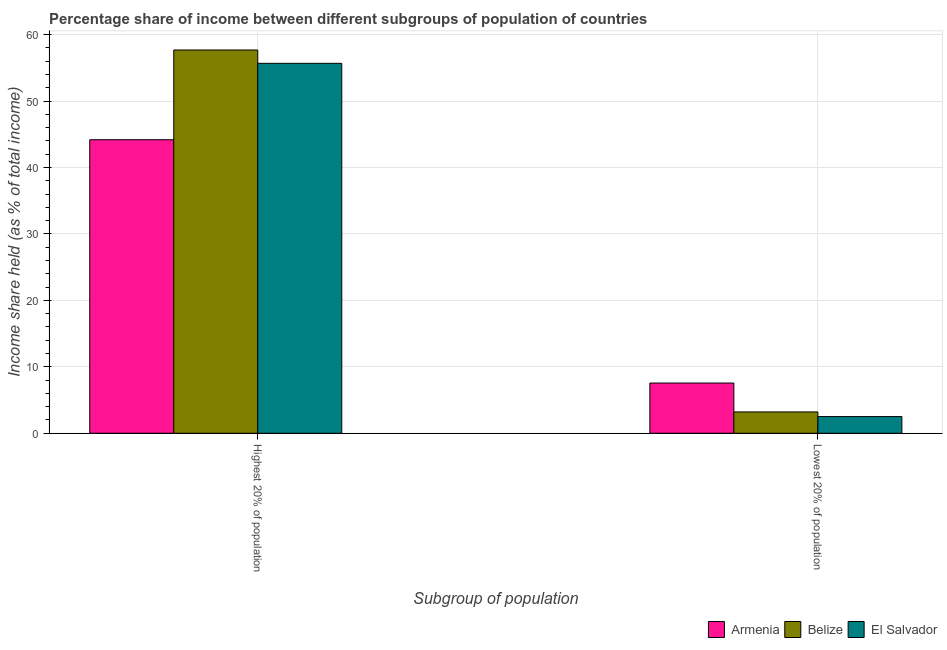How many groups of bars are there?
Offer a terse response. 2. Are the number of bars per tick equal to the number of legend labels?
Provide a succinct answer. Yes. What is the label of the 1st group of bars from the left?
Your response must be concise. Highest 20% of population. What is the income share held by lowest 20% of the population in El Salvador?
Provide a succinct answer. 2.51. Across all countries, what is the maximum income share held by highest 20% of the population?
Give a very brief answer. 57.69. Across all countries, what is the minimum income share held by lowest 20% of the population?
Your response must be concise. 2.51. In which country was the income share held by lowest 20% of the population maximum?
Your response must be concise. Armenia. In which country was the income share held by lowest 20% of the population minimum?
Your answer should be very brief. El Salvador. What is the total income share held by lowest 20% of the population in the graph?
Offer a terse response. 13.28. What is the difference between the income share held by highest 20% of the population in Armenia and that in El Salvador?
Your answer should be compact. -11.5. What is the difference between the income share held by highest 20% of the population in El Salvador and the income share held by lowest 20% of the population in Armenia?
Keep it short and to the point. 48.12. What is the average income share held by highest 20% of the population per country?
Provide a short and direct response. 52.52. What is the difference between the income share held by highest 20% of the population and income share held by lowest 20% of the population in Armenia?
Your answer should be very brief. 36.62. In how many countries, is the income share held by highest 20% of the population greater than 4 %?
Provide a short and direct response. 3. What is the ratio of the income share held by lowest 20% of the population in Armenia to that in El Salvador?
Provide a succinct answer. 3.01. Is the income share held by lowest 20% of the population in Armenia less than that in El Salvador?
Provide a succinct answer. No. In how many countries, is the income share held by lowest 20% of the population greater than the average income share held by lowest 20% of the population taken over all countries?
Your answer should be compact. 1. What does the 2nd bar from the left in Lowest 20% of population represents?
Provide a succinct answer. Belize. What does the 3rd bar from the right in Highest 20% of population represents?
Make the answer very short. Armenia. Are all the bars in the graph horizontal?
Give a very brief answer. No. What is the difference between two consecutive major ticks on the Y-axis?
Keep it short and to the point. 10. Are the values on the major ticks of Y-axis written in scientific E-notation?
Offer a very short reply. No. Where does the legend appear in the graph?
Your answer should be compact. Bottom right. How are the legend labels stacked?
Your answer should be very brief. Horizontal. What is the title of the graph?
Make the answer very short. Percentage share of income between different subgroups of population of countries. Does "Malaysia" appear as one of the legend labels in the graph?
Your answer should be compact. No. What is the label or title of the X-axis?
Ensure brevity in your answer.  Subgroup of population. What is the label or title of the Y-axis?
Your response must be concise. Income share held (as % of total income). What is the Income share held (as % of total income) in Armenia in Highest 20% of population?
Make the answer very short. 44.18. What is the Income share held (as % of total income) of Belize in Highest 20% of population?
Offer a very short reply. 57.69. What is the Income share held (as % of total income) in El Salvador in Highest 20% of population?
Offer a very short reply. 55.68. What is the Income share held (as % of total income) of Armenia in Lowest 20% of population?
Make the answer very short. 7.56. What is the Income share held (as % of total income) of Belize in Lowest 20% of population?
Make the answer very short. 3.21. What is the Income share held (as % of total income) in El Salvador in Lowest 20% of population?
Give a very brief answer. 2.51. Across all Subgroup of population, what is the maximum Income share held (as % of total income) in Armenia?
Ensure brevity in your answer.  44.18. Across all Subgroup of population, what is the maximum Income share held (as % of total income) in Belize?
Your response must be concise. 57.69. Across all Subgroup of population, what is the maximum Income share held (as % of total income) of El Salvador?
Ensure brevity in your answer.  55.68. Across all Subgroup of population, what is the minimum Income share held (as % of total income) of Armenia?
Make the answer very short. 7.56. Across all Subgroup of population, what is the minimum Income share held (as % of total income) of Belize?
Your response must be concise. 3.21. Across all Subgroup of population, what is the minimum Income share held (as % of total income) of El Salvador?
Ensure brevity in your answer.  2.51. What is the total Income share held (as % of total income) in Armenia in the graph?
Your answer should be very brief. 51.74. What is the total Income share held (as % of total income) of Belize in the graph?
Provide a short and direct response. 60.9. What is the total Income share held (as % of total income) in El Salvador in the graph?
Your answer should be very brief. 58.19. What is the difference between the Income share held (as % of total income) in Armenia in Highest 20% of population and that in Lowest 20% of population?
Your response must be concise. 36.62. What is the difference between the Income share held (as % of total income) in Belize in Highest 20% of population and that in Lowest 20% of population?
Your answer should be compact. 54.48. What is the difference between the Income share held (as % of total income) of El Salvador in Highest 20% of population and that in Lowest 20% of population?
Offer a very short reply. 53.17. What is the difference between the Income share held (as % of total income) of Armenia in Highest 20% of population and the Income share held (as % of total income) of Belize in Lowest 20% of population?
Keep it short and to the point. 40.97. What is the difference between the Income share held (as % of total income) of Armenia in Highest 20% of population and the Income share held (as % of total income) of El Salvador in Lowest 20% of population?
Ensure brevity in your answer.  41.67. What is the difference between the Income share held (as % of total income) in Belize in Highest 20% of population and the Income share held (as % of total income) in El Salvador in Lowest 20% of population?
Keep it short and to the point. 55.18. What is the average Income share held (as % of total income) of Armenia per Subgroup of population?
Provide a succinct answer. 25.87. What is the average Income share held (as % of total income) of Belize per Subgroup of population?
Give a very brief answer. 30.45. What is the average Income share held (as % of total income) of El Salvador per Subgroup of population?
Your answer should be compact. 29.09. What is the difference between the Income share held (as % of total income) of Armenia and Income share held (as % of total income) of Belize in Highest 20% of population?
Your answer should be very brief. -13.51. What is the difference between the Income share held (as % of total income) of Armenia and Income share held (as % of total income) of El Salvador in Highest 20% of population?
Ensure brevity in your answer.  -11.5. What is the difference between the Income share held (as % of total income) in Belize and Income share held (as % of total income) in El Salvador in Highest 20% of population?
Your answer should be compact. 2.01. What is the difference between the Income share held (as % of total income) of Armenia and Income share held (as % of total income) of Belize in Lowest 20% of population?
Your answer should be very brief. 4.35. What is the difference between the Income share held (as % of total income) in Armenia and Income share held (as % of total income) in El Salvador in Lowest 20% of population?
Offer a terse response. 5.05. What is the difference between the Income share held (as % of total income) of Belize and Income share held (as % of total income) of El Salvador in Lowest 20% of population?
Make the answer very short. 0.7. What is the ratio of the Income share held (as % of total income) in Armenia in Highest 20% of population to that in Lowest 20% of population?
Offer a terse response. 5.84. What is the ratio of the Income share held (as % of total income) in Belize in Highest 20% of population to that in Lowest 20% of population?
Your response must be concise. 17.97. What is the ratio of the Income share held (as % of total income) in El Salvador in Highest 20% of population to that in Lowest 20% of population?
Give a very brief answer. 22.18. What is the difference between the highest and the second highest Income share held (as % of total income) in Armenia?
Offer a terse response. 36.62. What is the difference between the highest and the second highest Income share held (as % of total income) in Belize?
Offer a terse response. 54.48. What is the difference between the highest and the second highest Income share held (as % of total income) of El Salvador?
Keep it short and to the point. 53.17. What is the difference between the highest and the lowest Income share held (as % of total income) in Armenia?
Offer a very short reply. 36.62. What is the difference between the highest and the lowest Income share held (as % of total income) in Belize?
Give a very brief answer. 54.48. What is the difference between the highest and the lowest Income share held (as % of total income) in El Salvador?
Your response must be concise. 53.17. 